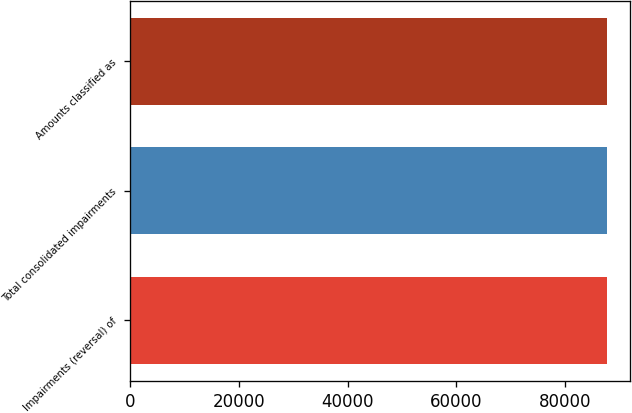Convert chart to OTSL. <chart><loc_0><loc_0><loc_500><loc_500><bar_chart><fcel>Impairments (reversal) of<fcel>Total consolidated impairments<fcel>Amounts classified as<nl><fcel>87613<fcel>87613.8<fcel>87605<nl></chart> 